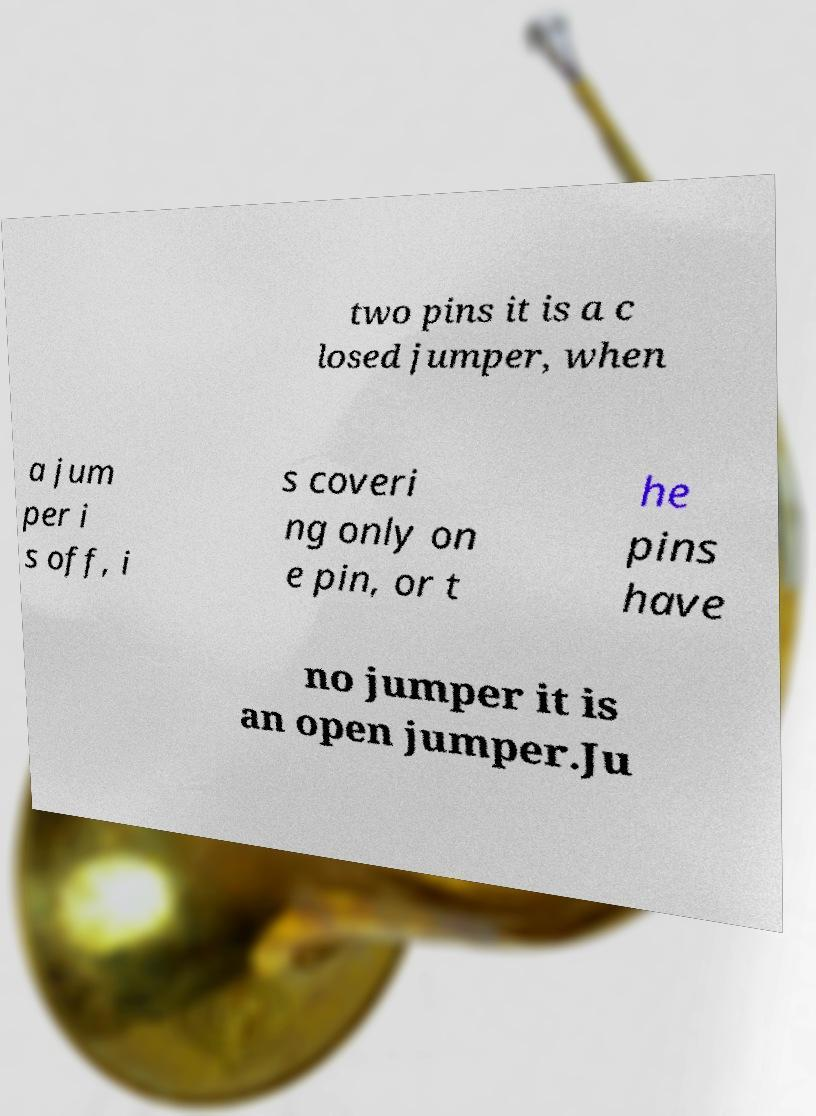Please identify and transcribe the text found in this image. two pins it is a c losed jumper, when a jum per i s off, i s coveri ng only on e pin, or t he pins have no jumper it is an open jumper.Ju 